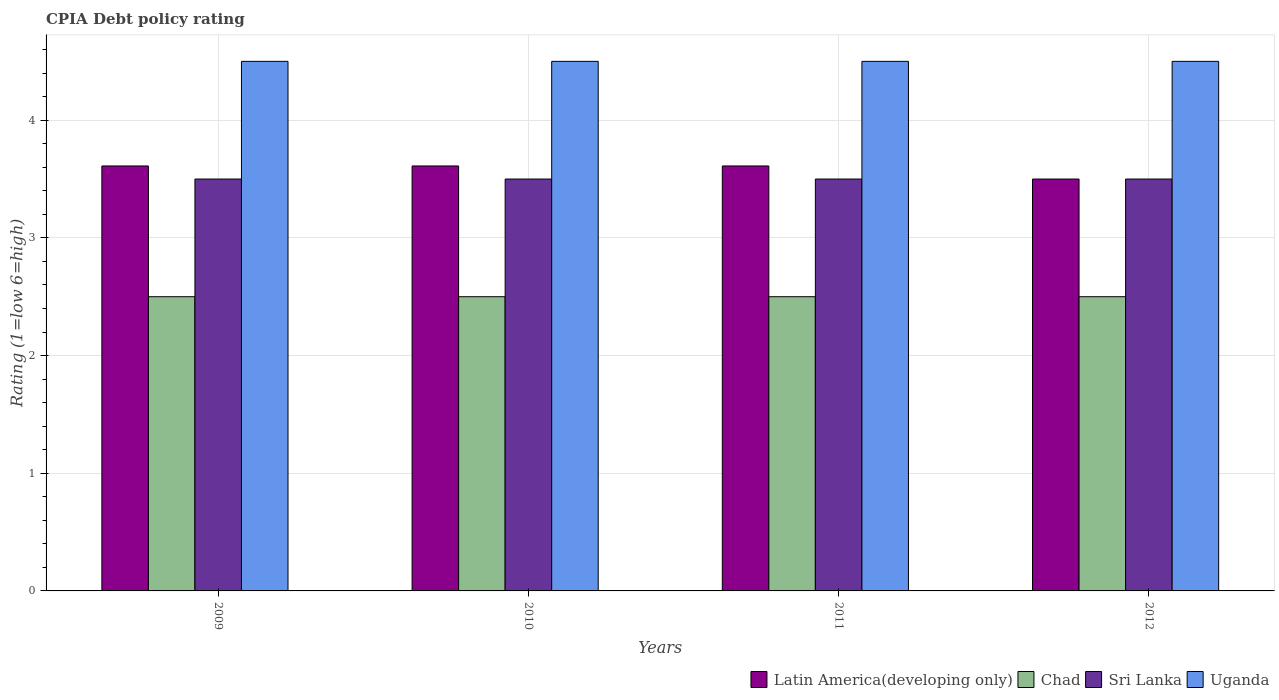How many groups of bars are there?
Your answer should be compact. 4. Are the number of bars per tick equal to the number of legend labels?
Give a very brief answer. Yes. Are the number of bars on each tick of the X-axis equal?
Give a very brief answer. Yes. How many bars are there on the 4th tick from the right?
Provide a short and direct response. 4. In how many cases, is the number of bars for a given year not equal to the number of legend labels?
Offer a very short reply. 0. What is the CPIA rating in Latin America(developing only) in 2011?
Offer a terse response. 3.61. In which year was the CPIA rating in Sri Lanka maximum?
Ensure brevity in your answer.  2009. What is the difference between the CPIA rating in Latin America(developing only) in 2009 and that in 2010?
Give a very brief answer. 0. What is the average CPIA rating in Chad per year?
Keep it short and to the point. 2.5. In the year 2010, what is the difference between the CPIA rating in Uganda and CPIA rating in Chad?
Your response must be concise. 2. In how many years, is the CPIA rating in Latin America(developing only) greater than 4.2?
Offer a terse response. 0. What is the ratio of the CPIA rating in Sri Lanka in 2010 to that in 2012?
Make the answer very short. 1. Is the difference between the CPIA rating in Uganda in 2010 and 2011 greater than the difference between the CPIA rating in Chad in 2010 and 2011?
Ensure brevity in your answer.  No. In how many years, is the CPIA rating in Chad greater than the average CPIA rating in Chad taken over all years?
Provide a succinct answer. 0. Is the sum of the CPIA rating in Chad in 2009 and 2010 greater than the maximum CPIA rating in Latin America(developing only) across all years?
Your answer should be very brief. Yes. What does the 4th bar from the left in 2010 represents?
Make the answer very short. Uganda. What does the 1st bar from the right in 2012 represents?
Make the answer very short. Uganda. Is it the case that in every year, the sum of the CPIA rating in Latin America(developing only) and CPIA rating in Chad is greater than the CPIA rating in Uganda?
Offer a very short reply. Yes. Are the values on the major ticks of Y-axis written in scientific E-notation?
Your answer should be compact. No. Does the graph contain any zero values?
Ensure brevity in your answer.  No. How are the legend labels stacked?
Keep it short and to the point. Horizontal. What is the title of the graph?
Your response must be concise. CPIA Debt policy rating. What is the label or title of the X-axis?
Make the answer very short. Years. What is the label or title of the Y-axis?
Offer a terse response. Rating (1=low 6=high). What is the Rating (1=low 6=high) of Latin America(developing only) in 2009?
Make the answer very short. 3.61. What is the Rating (1=low 6=high) in Chad in 2009?
Give a very brief answer. 2.5. What is the Rating (1=low 6=high) in Sri Lanka in 2009?
Keep it short and to the point. 3.5. What is the Rating (1=low 6=high) in Latin America(developing only) in 2010?
Your answer should be very brief. 3.61. What is the Rating (1=low 6=high) of Uganda in 2010?
Your response must be concise. 4.5. What is the Rating (1=low 6=high) in Latin America(developing only) in 2011?
Ensure brevity in your answer.  3.61. What is the Rating (1=low 6=high) of Chad in 2012?
Make the answer very short. 2.5. Across all years, what is the maximum Rating (1=low 6=high) of Latin America(developing only)?
Ensure brevity in your answer.  3.61. Across all years, what is the maximum Rating (1=low 6=high) of Chad?
Offer a very short reply. 2.5. Across all years, what is the maximum Rating (1=low 6=high) of Uganda?
Provide a short and direct response. 4.5. Across all years, what is the minimum Rating (1=low 6=high) in Latin America(developing only)?
Give a very brief answer. 3.5. Across all years, what is the minimum Rating (1=low 6=high) of Chad?
Provide a short and direct response. 2.5. Across all years, what is the minimum Rating (1=low 6=high) of Uganda?
Keep it short and to the point. 4.5. What is the total Rating (1=low 6=high) of Latin America(developing only) in the graph?
Your answer should be very brief. 14.33. What is the total Rating (1=low 6=high) in Uganda in the graph?
Offer a very short reply. 18. What is the difference between the Rating (1=low 6=high) of Latin America(developing only) in 2009 and that in 2010?
Give a very brief answer. 0. What is the difference between the Rating (1=low 6=high) of Sri Lanka in 2009 and that in 2010?
Provide a succinct answer. 0. What is the difference between the Rating (1=low 6=high) in Uganda in 2009 and that in 2010?
Give a very brief answer. 0. What is the difference between the Rating (1=low 6=high) of Latin America(developing only) in 2009 and that in 2011?
Make the answer very short. 0. What is the difference between the Rating (1=low 6=high) of Uganda in 2009 and that in 2011?
Offer a terse response. 0. What is the difference between the Rating (1=low 6=high) in Chad in 2009 and that in 2012?
Offer a very short reply. 0. What is the difference between the Rating (1=low 6=high) of Uganda in 2009 and that in 2012?
Give a very brief answer. 0. What is the difference between the Rating (1=low 6=high) of Latin America(developing only) in 2010 and that in 2011?
Ensure brevity in your answer.  0. What is the difference between the Rating (1=low 6=high) in Uganda in 2010 and that in 2011?
Give a very brief answer. 0. What is the difference between the Rating (1=low 6=high) of Chad in 2010 and that in 2012?
Your answer should be very brief. 0. What is the difference between the Rating (1=low 6=high) in Sri Lanka in 2010 and that in 2012?
Ensure brevity in your answer.  0. What is the difference between the Rating (1=low 6=high) of Latin America(developing only) in 2009 and the Rating (1=low 6=high) of Uganda in 2010?
Your answer should be compact. -0.89. What is the difference between the Rating (1=low 6=high) in Chad in 2009 and the Rating (1=low 6=high) in Uganda in 2010?
Your answer should be very brief. -2. What is the difference between the Rating (1=low 6=high) of Sri Lanka in 2009 and the Rating (1=low 6=high) of Uganda in 2010?
Provide a short and direct response. -1. What is the difference between the Rating (1=low 6=high) of Latin America(developing only) in 2009 and the Rating (1=low 6=high) of Sri Lanka in 2011?
Provide a short and direct response. 0.11. What is the difference between the Rating (1=low 6=high) of Latin America(developing only) in 2009 and the Rating (1=low 6=high) of Uganda in 2011?
Offer a terse response. -0.89. What is the difference between the Rating (1=low 6=high) in Chad in 2009 and the Rating (1=low 6=high) in Sri Lanka in 2011?
Offer a very short reply. -1. What is the difference between the Rating (1=low 6=high) of Sri Lanka in 2009 and the Rating (1=low 6=high) of Uganda in 2011?
Your response must be concise. -1. What is the difference between the Rating (1=low 6=high) of Latin America(developing only) in 2009 and the Rating (1=low 6=high) of Chad in 2012?
Offer a very short reply. 1.11. What is the difference between the Rating (1=low 6=high) of Latin America(developing only) in 2009 and the Rating (1=low 6=high) of Uganda in 2012?
Ensure brevity in your answer.  -0.89. What is the difference between the Rating (1=low 6=high) of Sri Lanka in 2009 and the Rating (1=low 6=high) of Uganda in 2012?
Keep it short and to the point. -1. What is the difference between the Rating (1=low 6=high) of Latin America(developing only) in 2010 and the Rating (1=low 6=high) of Sri Lanka in 2011?
Provide a succinct answer. 0.11. What is the difference between the Rating (1=low 6=high) of Latin America(developing only) in 2010 and the Rating (1=low 6=high) of Uganda in 2011?
Give a very brief answer. -0.89. What is the difference between the Rating (1=low 6=high) of Latin America(developing only) in 2010 and the Rating (1=low 6=high) of Sri Lanka in 2012?
Make the answer very short. 0.11. What is the difference between the Rating (1=low 6=high) in Latin America(developing only) in 2010 and the Rating (1=low 6=high) in Uganda in 2012?
Your response must be concise. -0.89. What is the difference between the Rating (1=low 6=high) in Chad in 2010 and the Rating (1=low 6=high) in Uganda in 2012?
Your answer should be very brief. -2. What is the difference between the Rating (1=low 6=high) in Sri Lanka in 2010 and the Rating (1=low 6=high) in Uganda in 2012?
Give a very brief answer. -1. What is the difference between the Rating (1=low 6=high) of Latin America(developing only) in 2011 and the Rating (1=low 6=high) of Chad in 2012?
Your answer should be compact. 1.11. What is the difference between the Rating (1=low 6=high) of Latin America(developing only) in 2011 and the Rating (1=low 6=high) of Sri Lanka in 2012?
Keep it short and to the point. 0.11. What is the difference between the Rating (1=low 6=high) of Latin America(developing only) in 2011 and the Rating (1=low 6=high) of Uganda in 2012?
Your answer should be very brief. -0.89. What is the difference between the Rating (1=low 6=high) in Chad in 2011 and the Rating (1=low 6=high) in Sri Lanka in 2012?
Your answer should be very brief. -1. What is the average Rating (1=low 6=high) of Latin America(developing only) per year?
Offer a very short reply. 3.58. What is the average Rating (1=low 6=high) in Sri Lanka per year?
Give a very brief answer. 3.5. What is the average Rating (1=low 6=high) of Uganda per year?
Your answer should be very brief. 4.5. In the year 2009, what is the difference between the Rating (1=low 6=high) in Latin America(developing only) and Rating (1=low 6=high) in Chad?
Offer a terse response. 1.11. In the year 2009, what is the difference between the Rating (1=low 6=high) in Latin America(developing only) and Rating (1=low 6=high) in Uganda?
Provide a succinct answer. -0.89. In the year 2009, what is the difference between the Rating (1=low 6=high) in Chad and Rating (1=low 6=high) in Uganda?
Make the answer very short. -2. In the year 2010, what is the difference between the Rating (1=low 6=high) of Latin America(developing only) and Rating (1=low 6=high) of Chad?
Give a very brief answer. 1.11. In the year 2010, what is the difference between the Rating (1=low 6=high) of Latin America(developing only) and Rating (1=low 6=high) of Uganda?
Provide a succinct answer. -0.89. In the year 2010, what is the difference between the Rating (1=low 6=high) in Chad and Rating (1=low 6=high) in Sri Lanka?
Make the answer very short. -1. In the year 2011, what is the difference between the Rating (1=low 6=high) in Latin America(developing only) and Rating (1=low 6=high) in Chad?
Your response must be concise. 1.11. In the year 2011, what is the difference between the Rating (1=low 6=high) of Latin America(developing only) and Rating (1=low 6=high) of Uganda?
Offer a very short reply. -0.89. In the year 2011, what is the difference between the Rating (1=low 6=high) of Chad and Rating (1=low 6=high) of Sri Lanka?
Provide a succinct answer. -1. In the year 2011, what is the difference between the Rating (1=low 6=high) of Chad and Rating (1=low 6=high) of Uganda?
Keep it short and to the point. -2. In the year 2012, what is the difference between the Rating (1=low 6=high) in Latin America(developing only) and Rating (1=low 6=high) in Sri Lanka?
Ensure brevity in your answer.  0. In the year 2012, what is the difference between the Rating (1=low 6=high) of Chad and Rating (1=low 6=high) of Sri Lanka?
Offer a very short reply. -1. In the year 2012, what is the difference between the Rating (1=low 6=high) in Sri Lanka and Rating (1=low 6=high) in Uganda?
Give a very brief answer. -1. What is the ratio of the Rating (1=low 6=high) of Latin America(developing only) in 2009 to that in 2010?
Offer a very short reply. 1. What is the ratio of the Rating (1=low 6=high) of Latin America(developing only) in 2009 to that in 2011?
Provide a succinct answer. 1. What is the ratio of the Rating (1=low 6=high) of Latin America(developing only) in 2009 to that in 2012?
Ensure brevity in your answer.  1.03. What is the ratio of the Rating (1=low 6=high) of Latin America(developing only) in 2010 to that in 2011?
Offer a terse response. 1. What is the ratio of the Rating (1=low 6=high) in Chad in 2010 to that in 2011?
Make the answer very short. 1. What is the ratio of the Rating (1=low 6=high) of Uganda in 2010 to that in 2011?
Offer a very short reply. 1. What is the ratio of the Rating (1=low 6=high) in Latin America(developing only) in 2010 to that in 2012?
Provide a short and direct response. 1.03. What is the ratio of the Rating (1=low 6=high) of Chad in 2010 to that in 2012?
Keep it short and to the point. 1. What is the ratio of the Rating (1=low 6=high) of Sri Lanka in 2010 to that in 2012?
Provide a short and direct response. 1. What is the ratio of the Rating (1=low 6=high) in Uganda in 2010 to that in 2012?
Your answer should be very brief. 1. What is the ratio of the Rating (1=low 6=high) of Latin America(developing only) in 2011 to that in 2012?
Provide a short and direct response. 1.03. What is the ratio of the Rating (1=low 6=high) in Chad in 2011 to that in 2012?
Give a very brief answer. 1. What is the difference between the highest and the second highest Rating (1=low 6=high) in Latin America(developing only)?
Keep it short and to the point. 0. What is the difference between the highest and the second highest Rating (1=low 6=high) of Chad?
Keep it short and to the point. 0. What is the difference between the highest and the lowest Rating (1=low 6=high) of Chad?
Give a very brief answer. 0. What is the difference between the highest and the lowest Rating (1=low 6=high) in Uganda?
Keep it short and to the point. 0. 